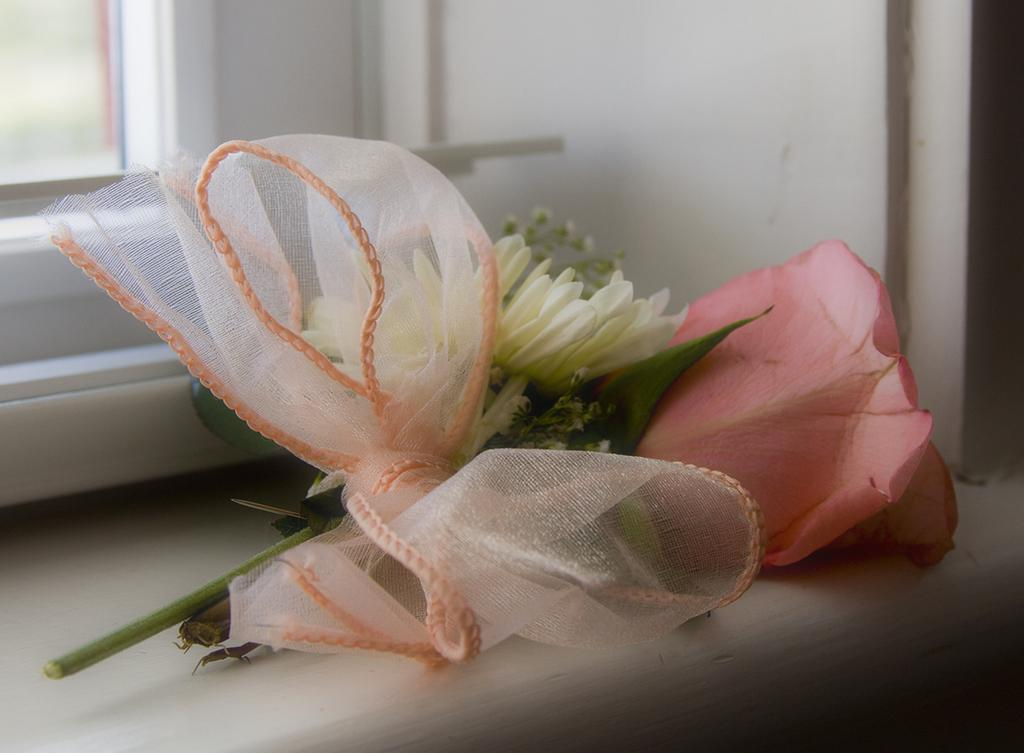What is the main subject of the image? The main subject of the image is flowers tied with a ribbon. Can you describe the flowers in the image? The flowers are tied with a ribbon. What is visible in the background of the image? There is a window visible in the background of the image. What type of veil can be seen on the wrist of the person in the image? There is no person or veil present in the image; it features flowers tied with a ribbon and a window in the background. 